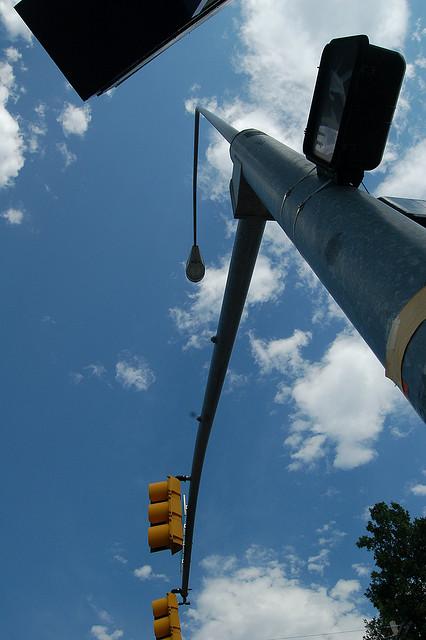What is this view of?
Short answer required. Sky. What color is the stop light?
Give a very brief answer. Yellow. How many clouds are in the sky?
Write a very short answer. 6. 